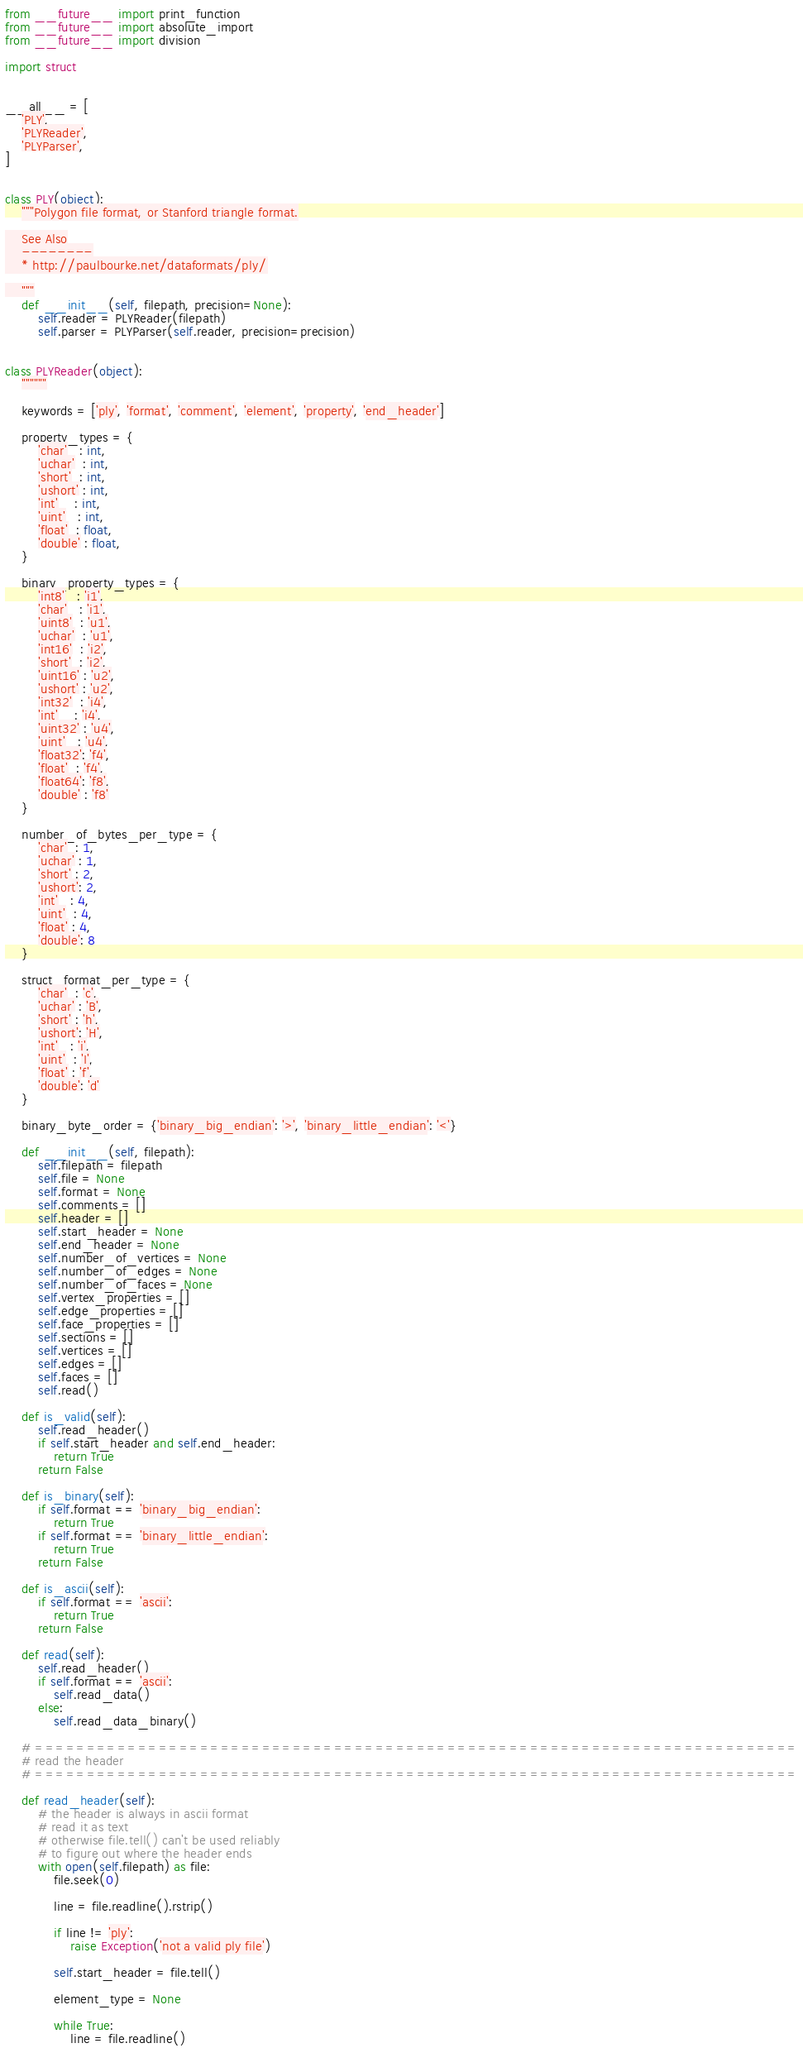<code> <loc_0><loc_0><loc_500><loc_500><_Python_>from __future__ import print_function
from __future__ import absolute_import
from __future__ import division

import struct


__all__ = [
    'PLY',
    'PLYReader',
    'PLYParser',
]


class PLY(object):
    """Polygon file format, or Stanford triangle format.

    See Also
    --------
    * http://paulbourke.net/dataformats/ply/

    """
    def __init__(self, filepath, precision=None):
        self.reader = PLYReader(filepath)
        self.parser = PLYParser(self.reader, precision=precision)


class PLYReader(object):
    """"""

    keywords = ['ply', 'format', 'comment', 'element', 'property', 'end_header']

    property_types = {
        'char'   : int,
        'uchar'  : int,
        'short'  : int,
        'ushort' : int,
        'int'    : int,
        'uint'   : int,
        'float'  : float,
        'double' : float,
    }

    binary_property_types = {
        'int8'   : 'i1',
        'char'   : 'i1',
        'uint8'  : 'u1',
        'uchar'  : 'u1',
        'int16'  : 'i2',
        'short'  : 'i2',
        'uint16' : 'u2',
        'ushort' : 'u2',
        'int32'  : 'i4',
        'int'    : 'i4',
        'uint32' : 'u4',
        'uint'   : 'u4',
        'float32': 'f4',
        'float'  : 'f4',
        'float64': 'f8',
        'double' : 'f8'
    }

    number_of_bytes_per_type = {
        'char'  : 1,
        'uchar' : 1,
        'short' : 2,
        'ushort': 2,
        'int'   : 4,
        'uint'  : 4,
        'float' : 4,
        'double': 8
    }

    struct_format_per_type = {
        'char'  : 'c',
        'uchar' : 'B',
        'short' : 'h',
        'ushort': 'H',
        'int'   : 'i',
        'uint'  : 'I',
        'float' : 'f',
        'double': 'd'
    }

    binary_byte_order = {'binary_big_endian': '>', 'binary_little_endian': '<'}

    def __init__(self, filepath):
        self.filepath = filepath
        self.file = None
        self.format = None
        self.comments = []
        self.header = []
        self.start_header = None
        self.end_header = None
        self.number_of_vertices = None
        self.number_of_edges = None
        self.number_of_faces = None
        self.vertex_properties = []
        self.edge_properties = []
        self.face_properties = []
        self.sections = []
        self.vertices = []
        self.edges = []
        self.faces = []
        self.read()

    def is_valid(self):
        self.read_header()
        if self.start_header and self.end_header:
            return True
        return False

    def is_binary(self):
        if self.format == 'binary_big_endian':
            return True
        if self.format == 'binary_little_endian':
            return True
        return False

    def is_ascii(self):
        if self.format == 'ascii':
            return True
        return False

    def read(self):
        self.read_header()
        if self.format == 'ascii':
            self.read_data()
        else:
            self.read_data_binary()

    # ==========================================================================
    # read the header
    # ==========================================================================

    def read_header(self):
        # the header is always in ascii format
        # read it as text
        # otherwise file.tell() can't be used reliably
        # to figure out where the header ends
        with open(self.filepath) as file:
            file.seek(0)

            line = file.readline().rstrip()

            if line != 'ply':
                raise Exception('not a valid ply file')

            self.start_header = file.tell()

            element_type = None

            while True:
                line = file.readline()</code> 